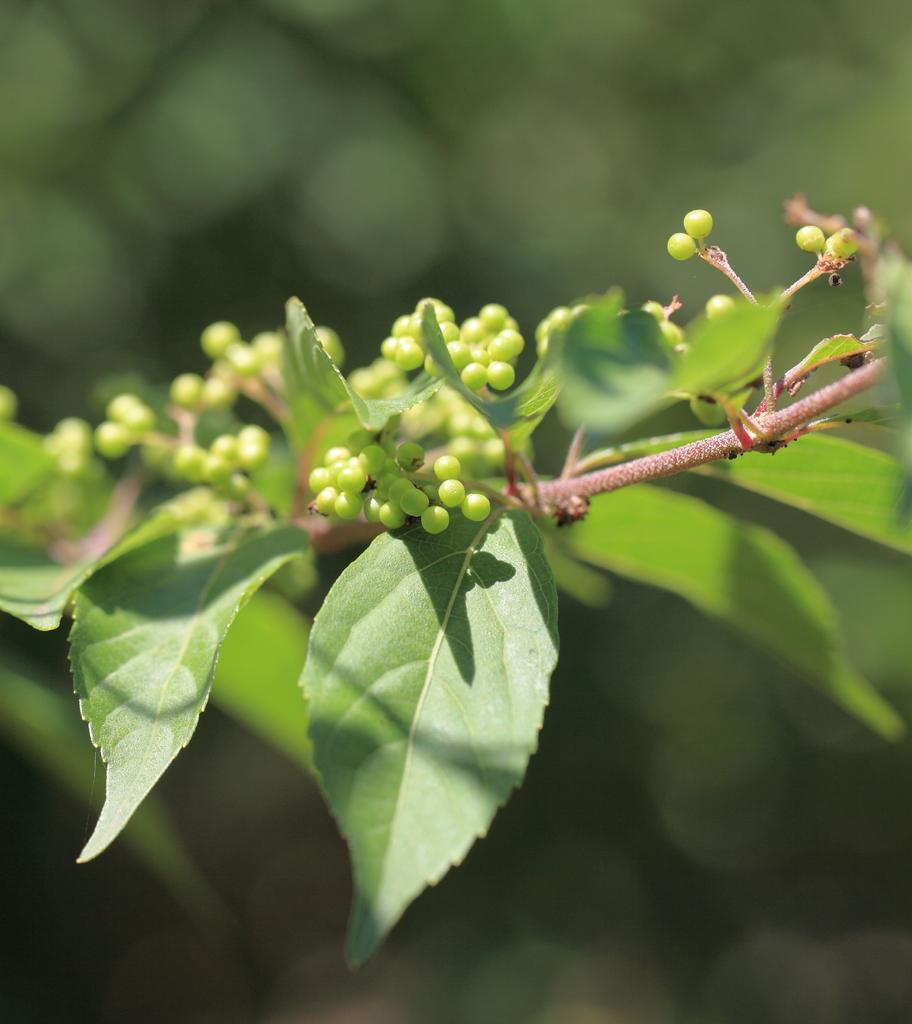What is the main subject of the image? The main subject of the image is a stem with leaves. What do the leaves resemble? The leaves appear to resemble seeds. How would you describe the background of the image? The background of the image is blurred. What type of pin can be seen holding the earth together in the image? There is no pin or earth present in the image; it features a stem with leaves and seeds. What type of wilderness can be seen in the background of the image? There is no wilderness visible in the image; the background is blurred. 